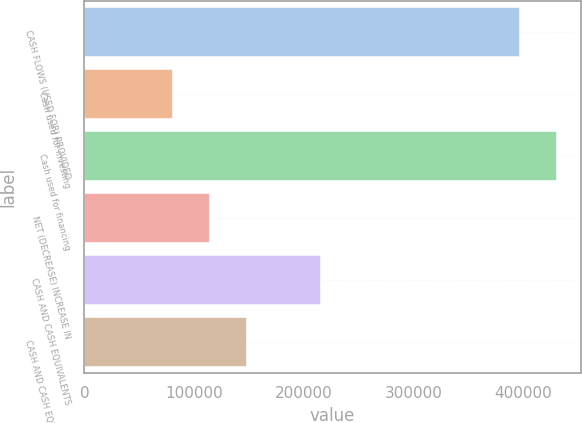Convert chart to OTSL. <chart><loc_0><loc_0><loc_500><loc_500><bar_chart><fcel>CASH FLOWS (USED FOR) PROVIDED<fcel>Cash used for investing<fcel>Cash used for financing<fcel>NET (DECREASE) INCREASE IN<fcel>CASH AND CASH EQUIVALENTS<fcel>CASH AND CASH EQUIVALENTS END<nl><fcel>397204<fcel>80534<fcel>431103<fcel>114433<fcel>215557<fcel>148332<nl></chart> 